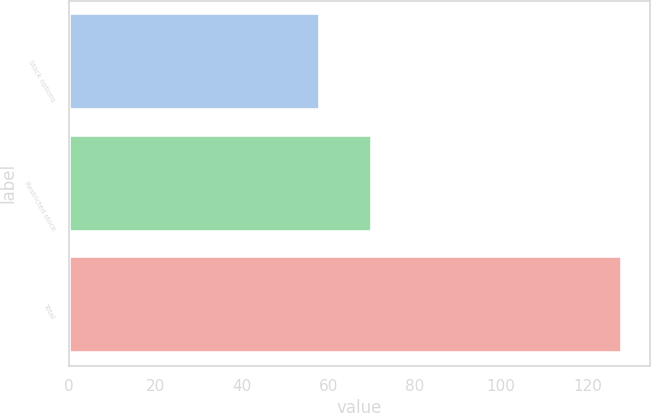Convert chart to OTSL. <chart><loc_0><loc_0><loc_500><loc_500><bar_chart><fcel>Stock options<fcel>Restricted stock<fcel>Total<nl><fcel>58<fcel>70<fcel>128<nl></chart> 